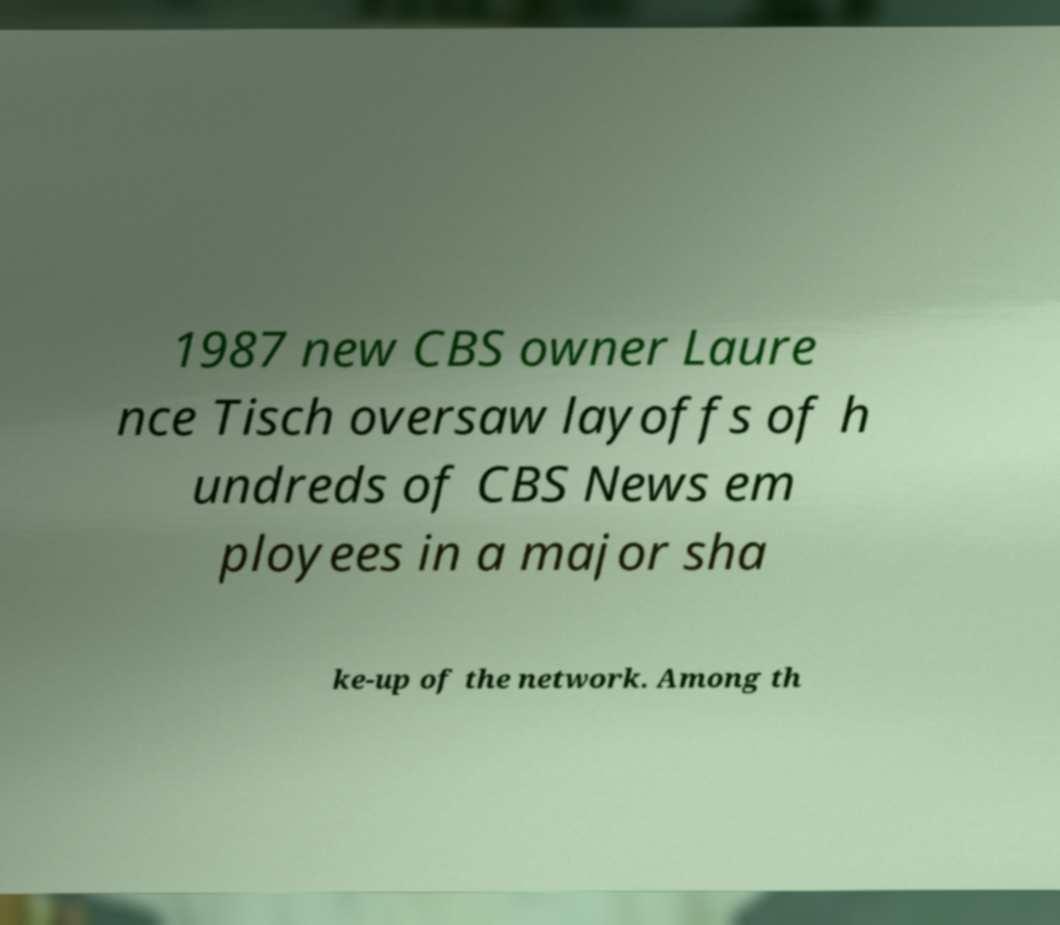What messages or text are displayed in this image? I need them in a readable, typed format. 1987 new CBS owner Laure nce Tisch oversaw layoffs of h undreds of CBS News em ployees in a major sha ke-up of the network. Among th 